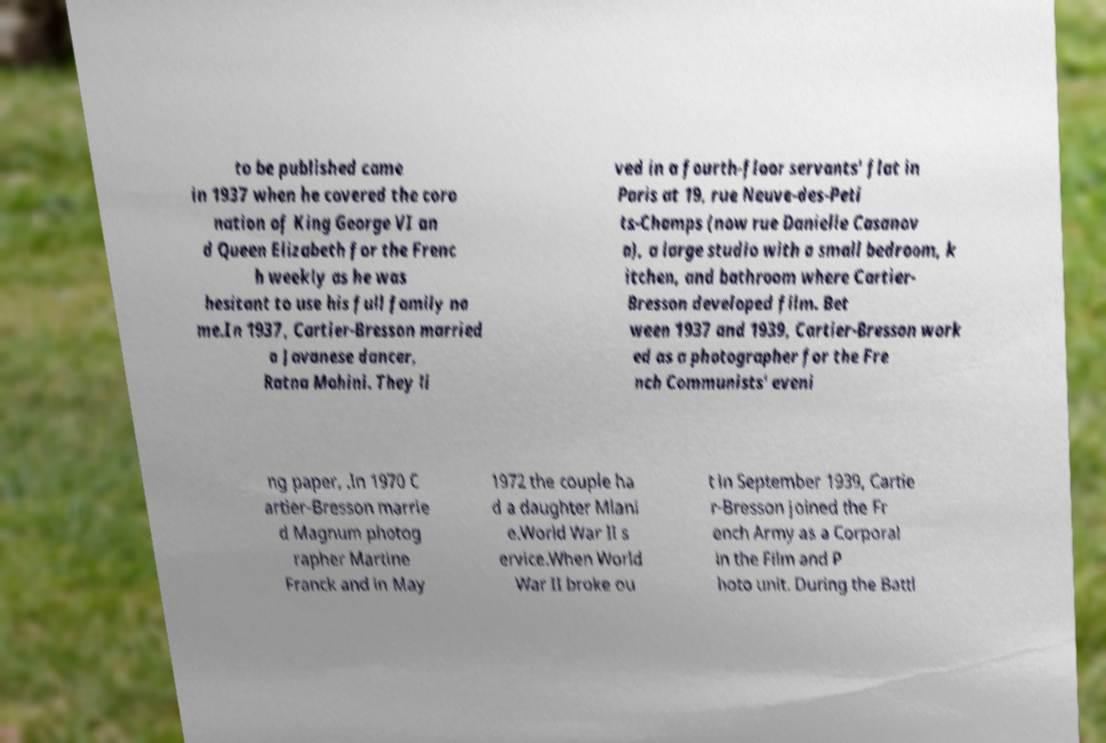There's text embedded in this image that I need extracted. Can you transcribe it verbatim? to be published came in 1937 when he covered the coro nation of King George VI an d Queen Elizabeth for the Frenc h weekly as he was hesitant to use his full family na me.In 1937, Cartier-Bresson married a Javanese dancer, Ratna Mohini. They li ved in a fourth-floor servants' flat in Paris at 19, rue Neuve-des-Peti ts-Champs (now rue Danielle Casanov a), a large studio with a small bedroom, k itchen, and bathroom where Cartier- Bresson developed film. Bet ween 1937 and 1939, Cartier-Bresson work ed as a photographer for the Fre nch Communists' eveni ng paper, .In 1970 C artier-Bresson marrie d Magnum photog rapher Martine Franck and in May 1972 the couple ha d a daughter Mlani e.World War II s ervice.When World War II broke ou t in September 1939, Cartie r-Bresson joined the Fr ench Army as a Corporal in the Film and P hoto unit. During the Battl 